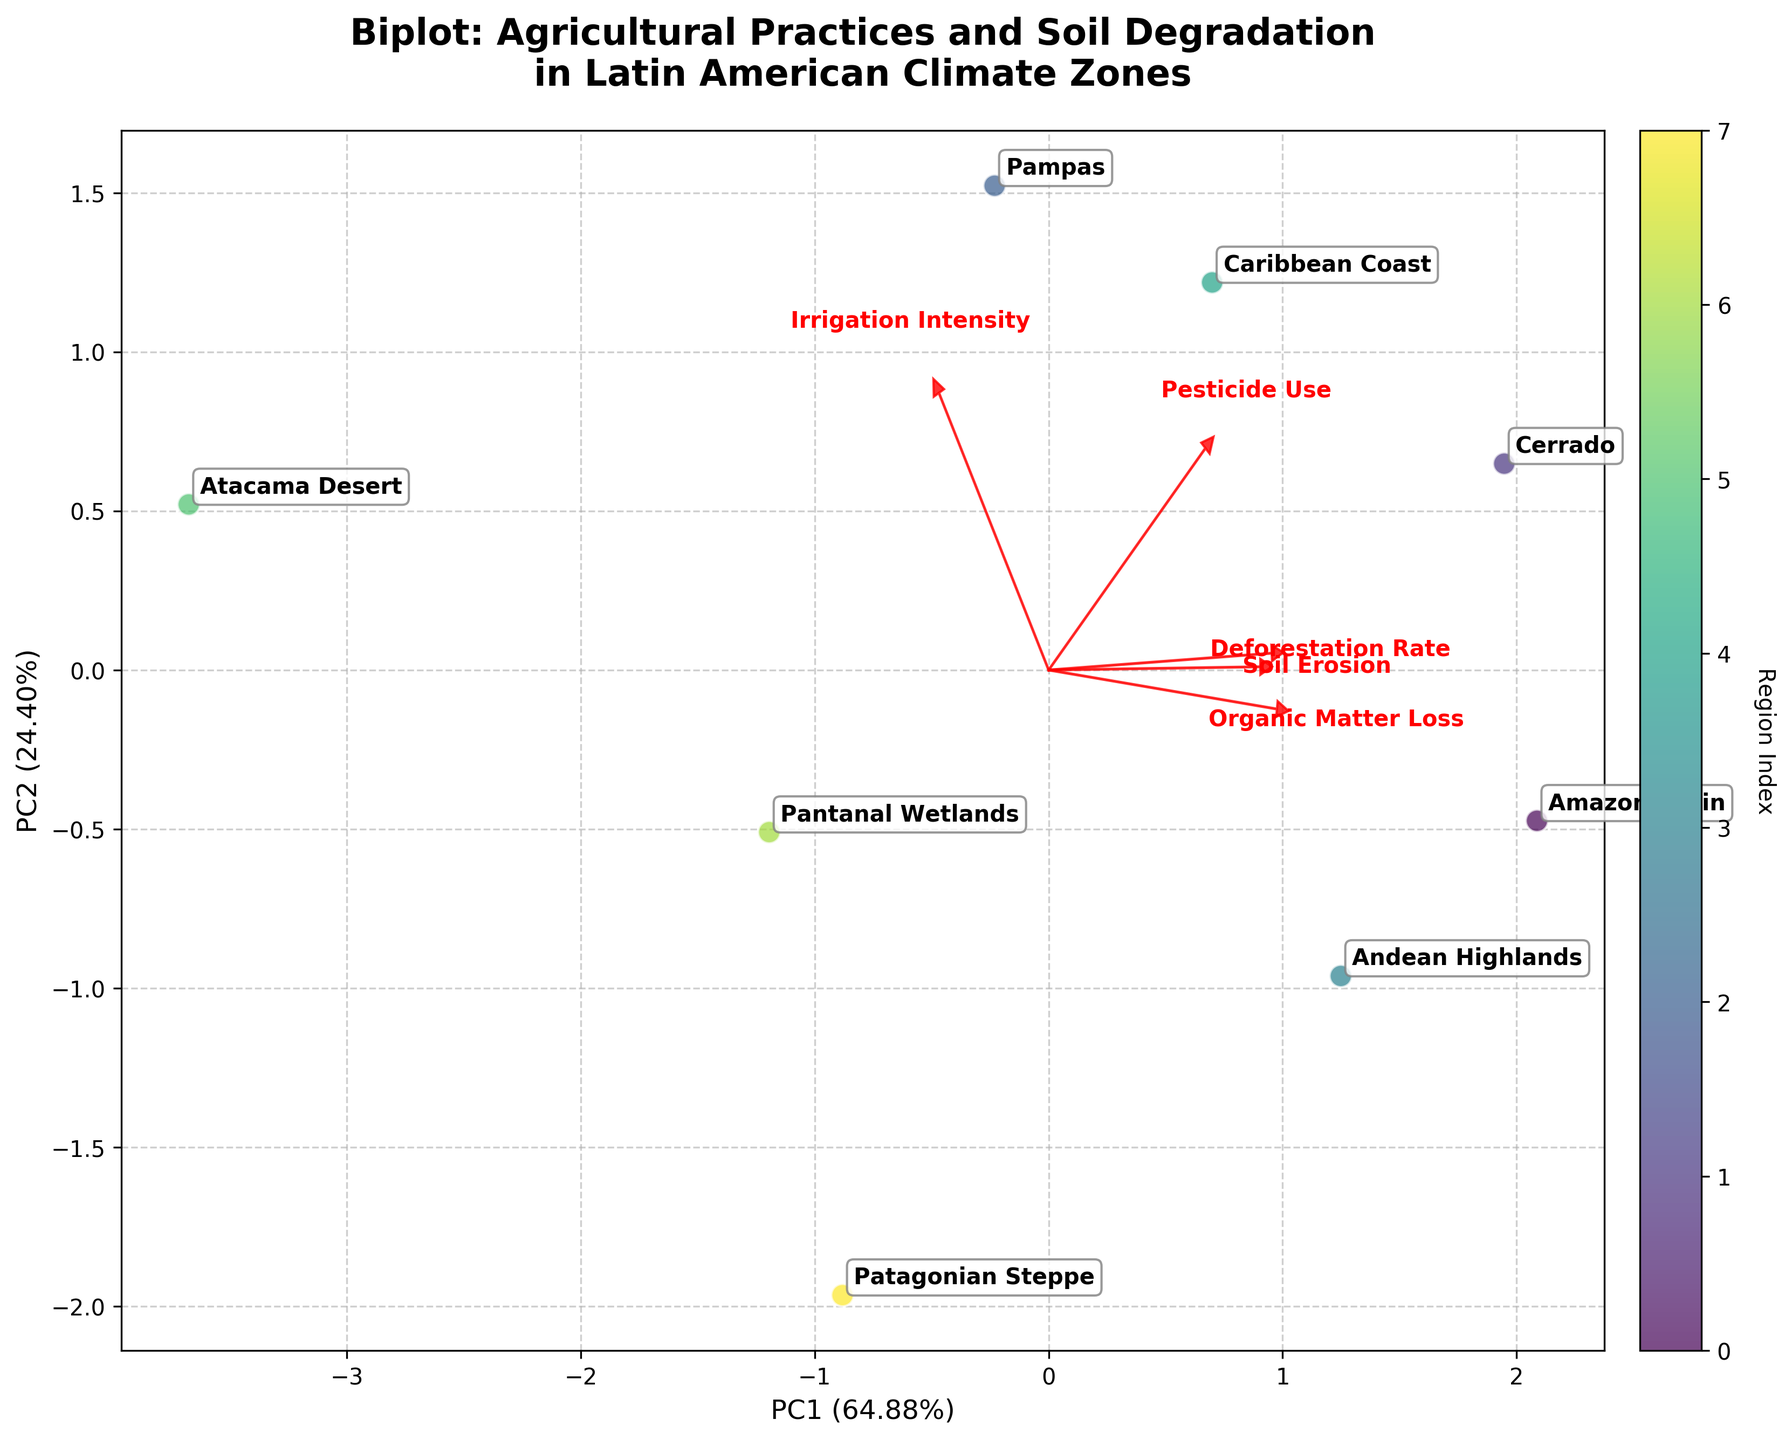what is the title of the biplot? It's located at the top of the figure and reads "Biplot: Agricultural Practices and Soil Degradation in Latin American Climate Zones."
Answer: Biplot: Agricultural Practices and Soil Degradation in Latin American Climate Zones Which region has the highest Soil Erosion value? Look for the region corresponding to the data point furthest in the direction of the red arrow labeled "Soil Erosion." This is the Andean Highlands.
Answer: Andean Highlands Which climate zone appears most correlated with high Pesticide Use? Look for the data point closest to the end of the red arrow labeled "Pesticide Use." This region is the Pampas.
Answer: Pampas How many climate zones are depicted in the biplot? Count the number of distinct data points in the scatter plot, each representing a different climate zone. There are eight such points.
Answer: Eight Which variable contributes most to PC1? Compare the lengths of red arrows in the direction of PC1. The longest arrow in this direction represents Soil Erosion.
Answer: Soil Erosion Which climate zone is most distant from the origin and in what direction? Find the point furthest from (0,0); this appears to be the Caribbean Coast, positioned in the positive direction of both PC1 and PC2.
Answer: Caribbean Coast; positive direction of both PC1 and PC2 Compare the Deforestation Rates of Amazon Basin and Cerrado, which one is higher? Look at the projections of the two regions in the direction of the red arrow labeled "Deforestation Rate." Cerrado has a smaller angle with this arrow, indicating a higher deforestation rate.
Answer: Cerrado What two variables have their vector arrows closely aligned, indicating a possible correlation? Look for pairs of red arrows that point in a similar direction. The arrows for Soil Erosion and Organic Matter Loss are closely aligned.
Answer: Soil Erosion and Organic Matter Loss Which region has the lowest Irrigation Intensity? Look for the region closest to the origin along the direction of the red arrow labeled "Irrigation Intensity." This region is the Patagonian Steppe.
Answer: Patagonian Steppe What percentage of the total variance is explained by the first two principal components? Add the percentages given in the axis labels for PC1 and PC2. The exact values need to be read off the plot titles, which are not provided in the data here.
Answer: Sum of given PC1 and PC2 values% 